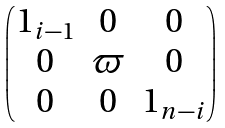Convert formula to latex. <formula><loc_0><loc_0><loc_500><loc_500>\begin{pmatrix} { 1 } _ { i - 1 } & 0 & 0 \\ 0 & \varpi & 0 \\ 0 & 0 & { 1 } _ { n - i } \end{pmatrix}</formula> 